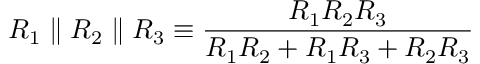Convert formula to latex. <formula><loc_0><loc_0><loc_500><loc_500>R _ { 1 } \| R _ { 2 } \| R _ { 3 } \equiv \frac { R _ { 1 } R _ { 2 } R _ { 3 } } { R _ { 1 } R _ { 2 } + R _ { 1 } R _ { 3 } + R _ { 2 } R _ { 3 } }</formula> 